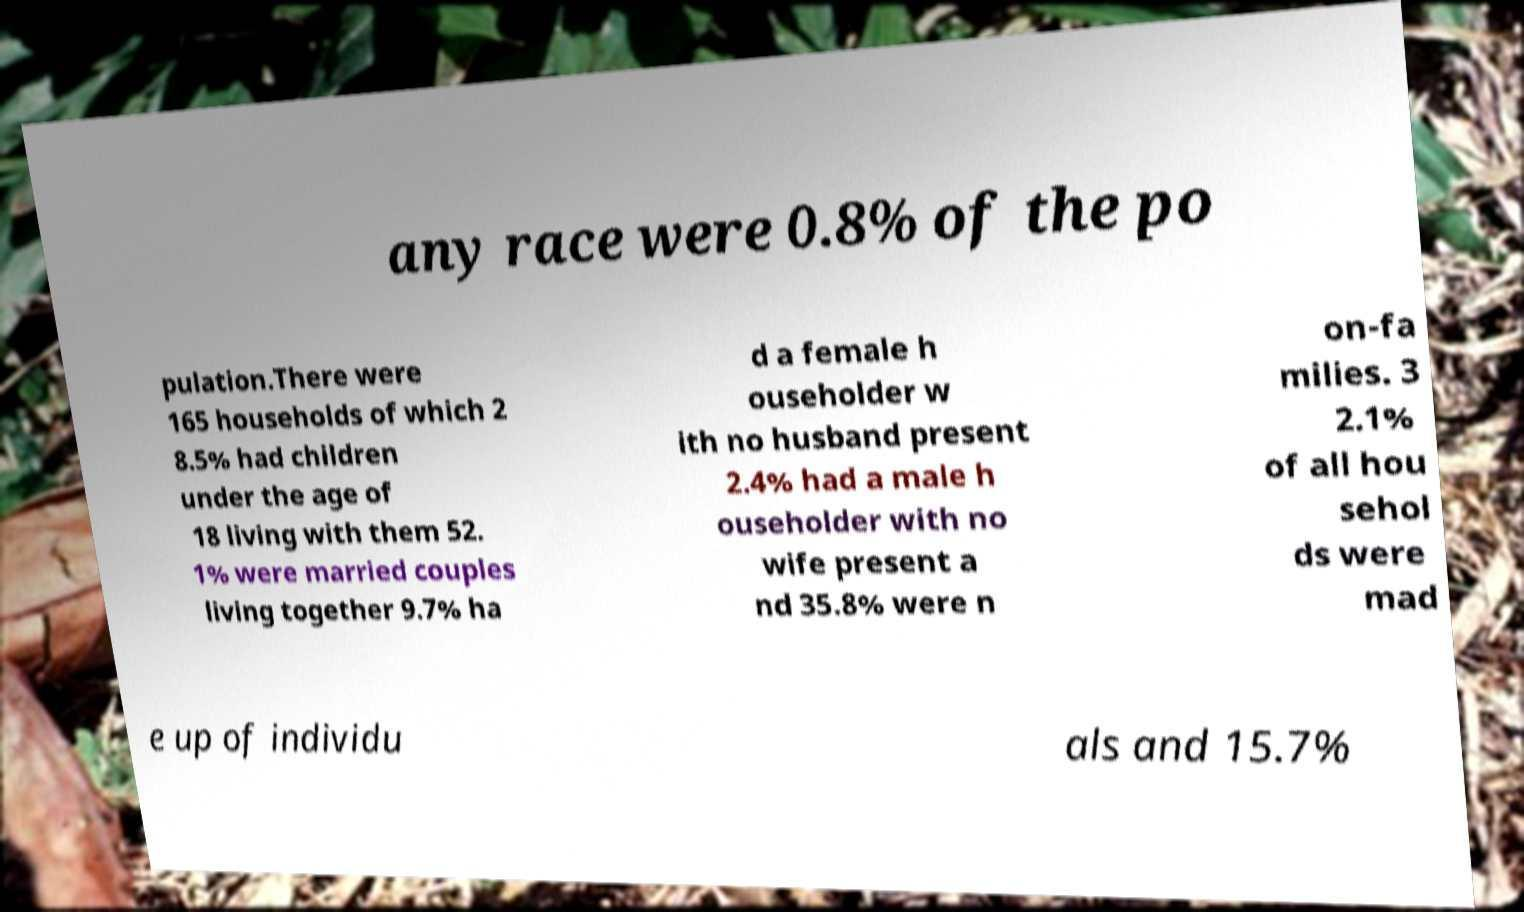Please identify and transcribe the text found in this image. any race were 0.8% of the po pulation.There were 165 households of which 2 8.5% had children under the age of 18 living with them 52. 1% were married couples living together 9.7% ha d a female h ouseholder w ith no husband present 2.4% had a male h ouseholder with no wife present a nd 35.8% were n on-fa milies. 3 2.1% of all hou sehol ds were mad e up of individu als and 15.7% 